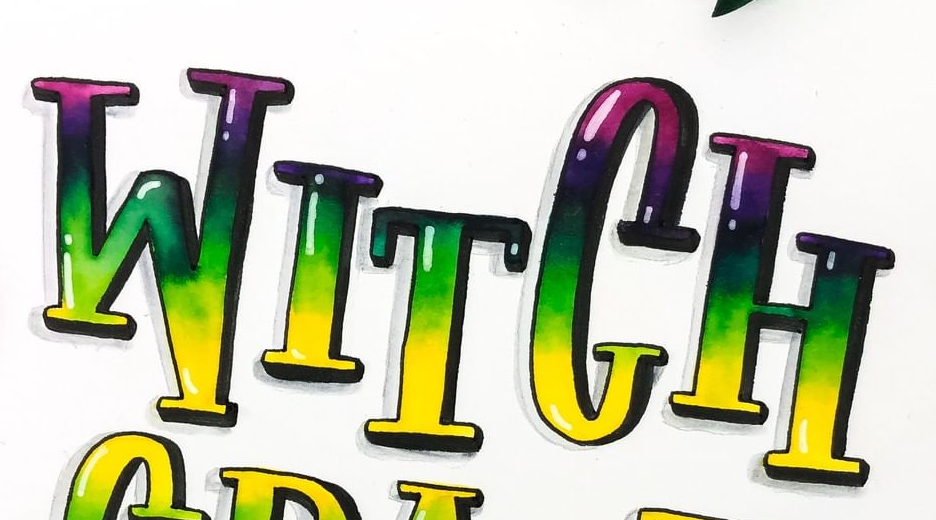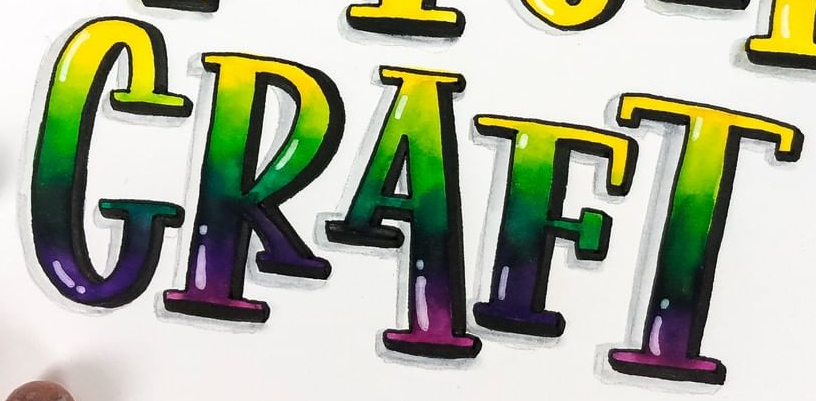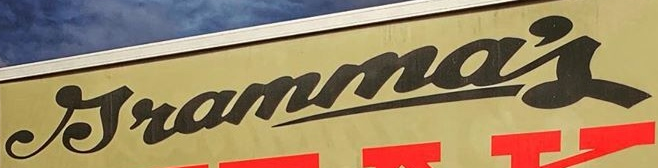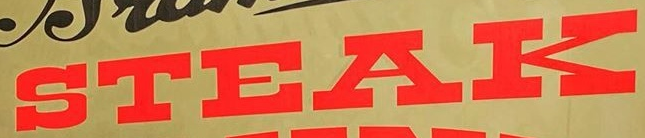What text is displayed in these images sequentially, separated by a semicolon? WITCH; CRAFT; Jramma's; STEAK 